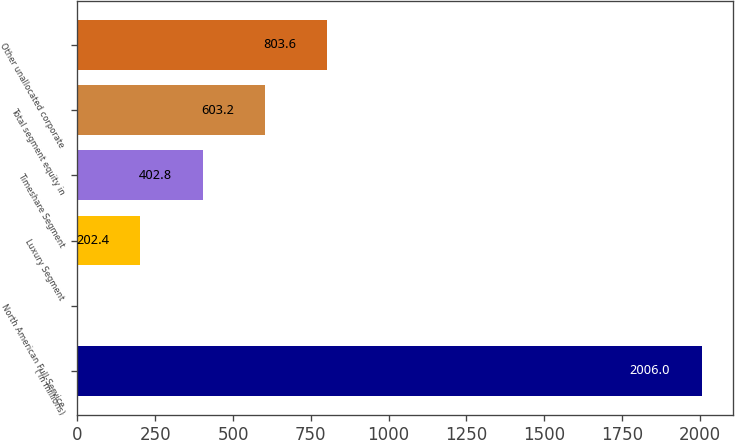<chart> <loc_0><loc_0><loc_500><loc_500><bar_chart><fcel>( in millions)<fcel>North American Full-Service<fcel>Luxury Segment<fcel>Timeshare Segment<fcel>Total segment equity in<fcel>Other unallocated corporate<nl><fcel>2006<fcel>2<fcel>202.4<fcel>402.8<fcel>603.2<fcel>803.6<nl></chart> 